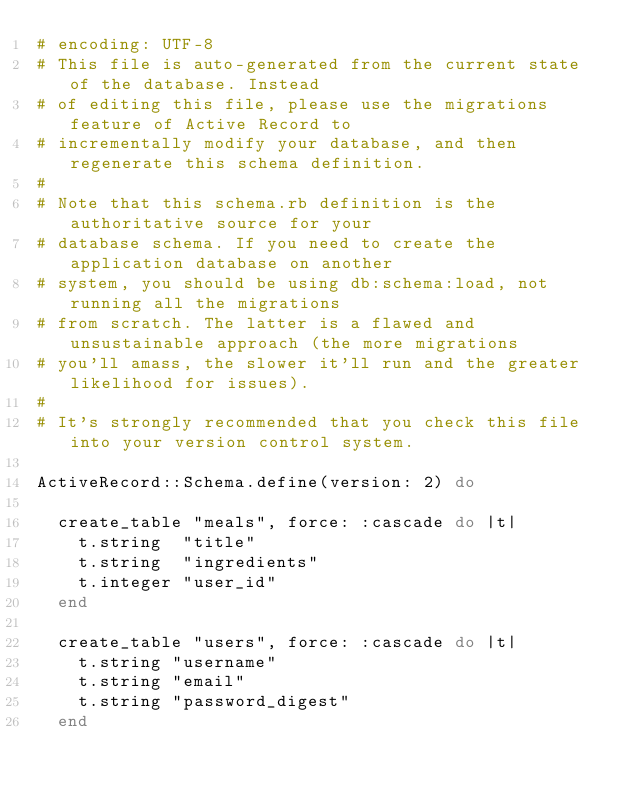<code> <loc_0><loc_0><loc_500><loc_500><_Ruby_># encoding: UTF-8
# This file is auto-generated from the current state of the database. Instead
# of editing this file, please use the migrations feature of Active Record to
# incrementally modify your database, and then regenerate this schema definition.
#
# Note that this schema.rb definition is the authoritative source for your
# database schema. If you need to create the application database on another
# system, you should be using db:schema:load, not running all the migrations
# from scratch. The latter is a flawed and unsustainable approach (the more migrations
# you'll amass, the slower it'll run and the greater likelihood for issues).
#
# It's strongly recommended that you check this file into your version control system.

ActiveRecord::Schema.define(version: 2) do

  create_table "meals", force: :cascade do |t|
    t.string  "title"
    t.string  "ingredients"
    t.integer "user_id"
  end

  create_table "users", force: :cascade do |t|
    t.string "username"
    t.string "email"
    t.string "password_digest"
  end
</code> 